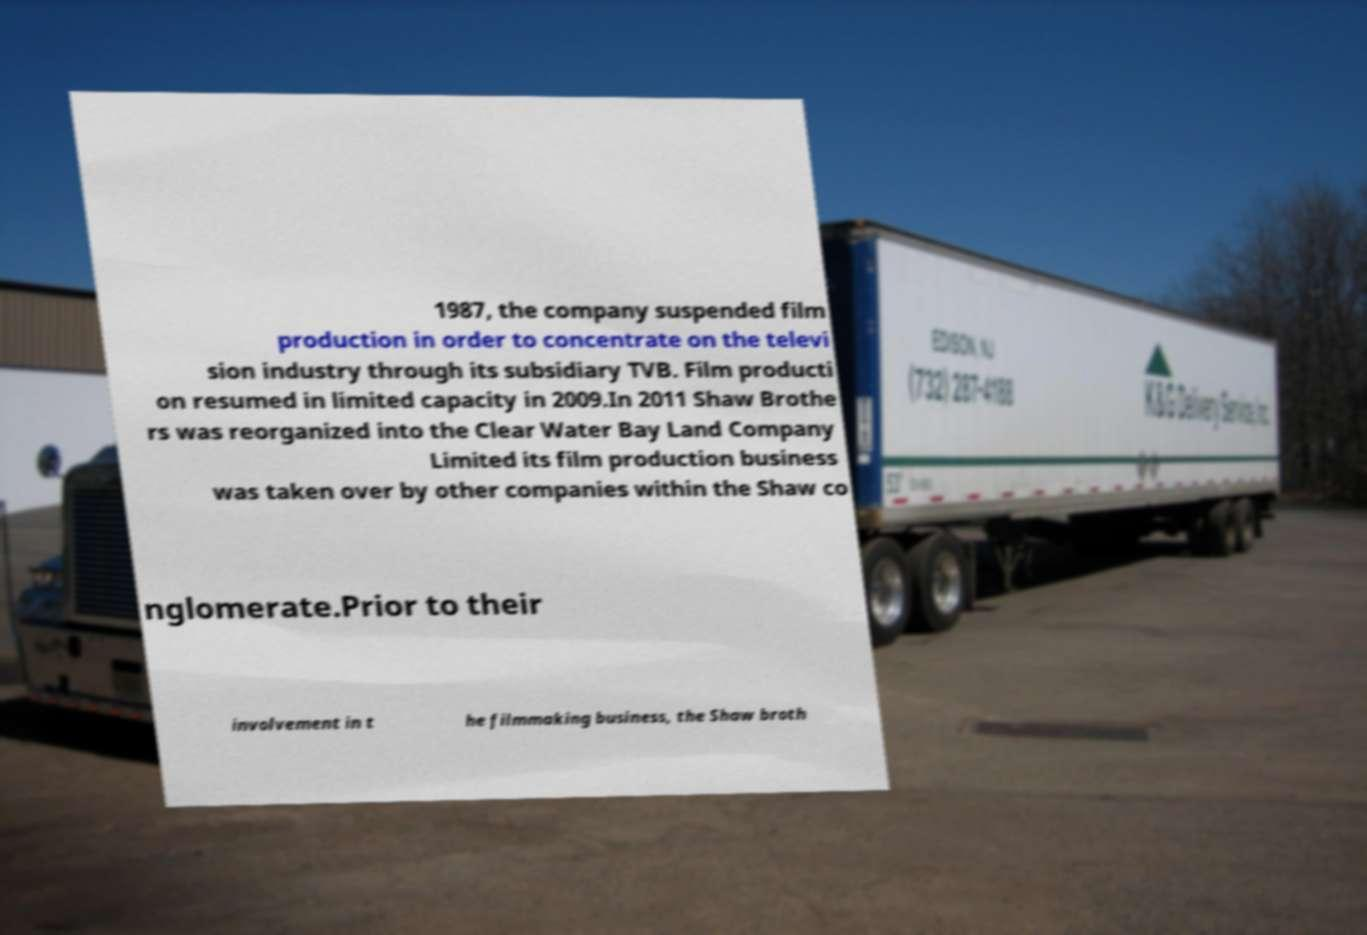Can you accurately transcribe the text from the provided image for me? 1987, the company suspended film production in order to concentrate on the televi sion industry through its subsidiary TVB. Film producti on resumed in limited capacity in 2009.In 2011 Shaw Brothe rs was reorganized into the Clear Water Bay Land Company Limited its film production business was taken over by other companies within the Shaw co nglomerate.Prior to their involvement in t he filmmaking business, the Shaw broth 